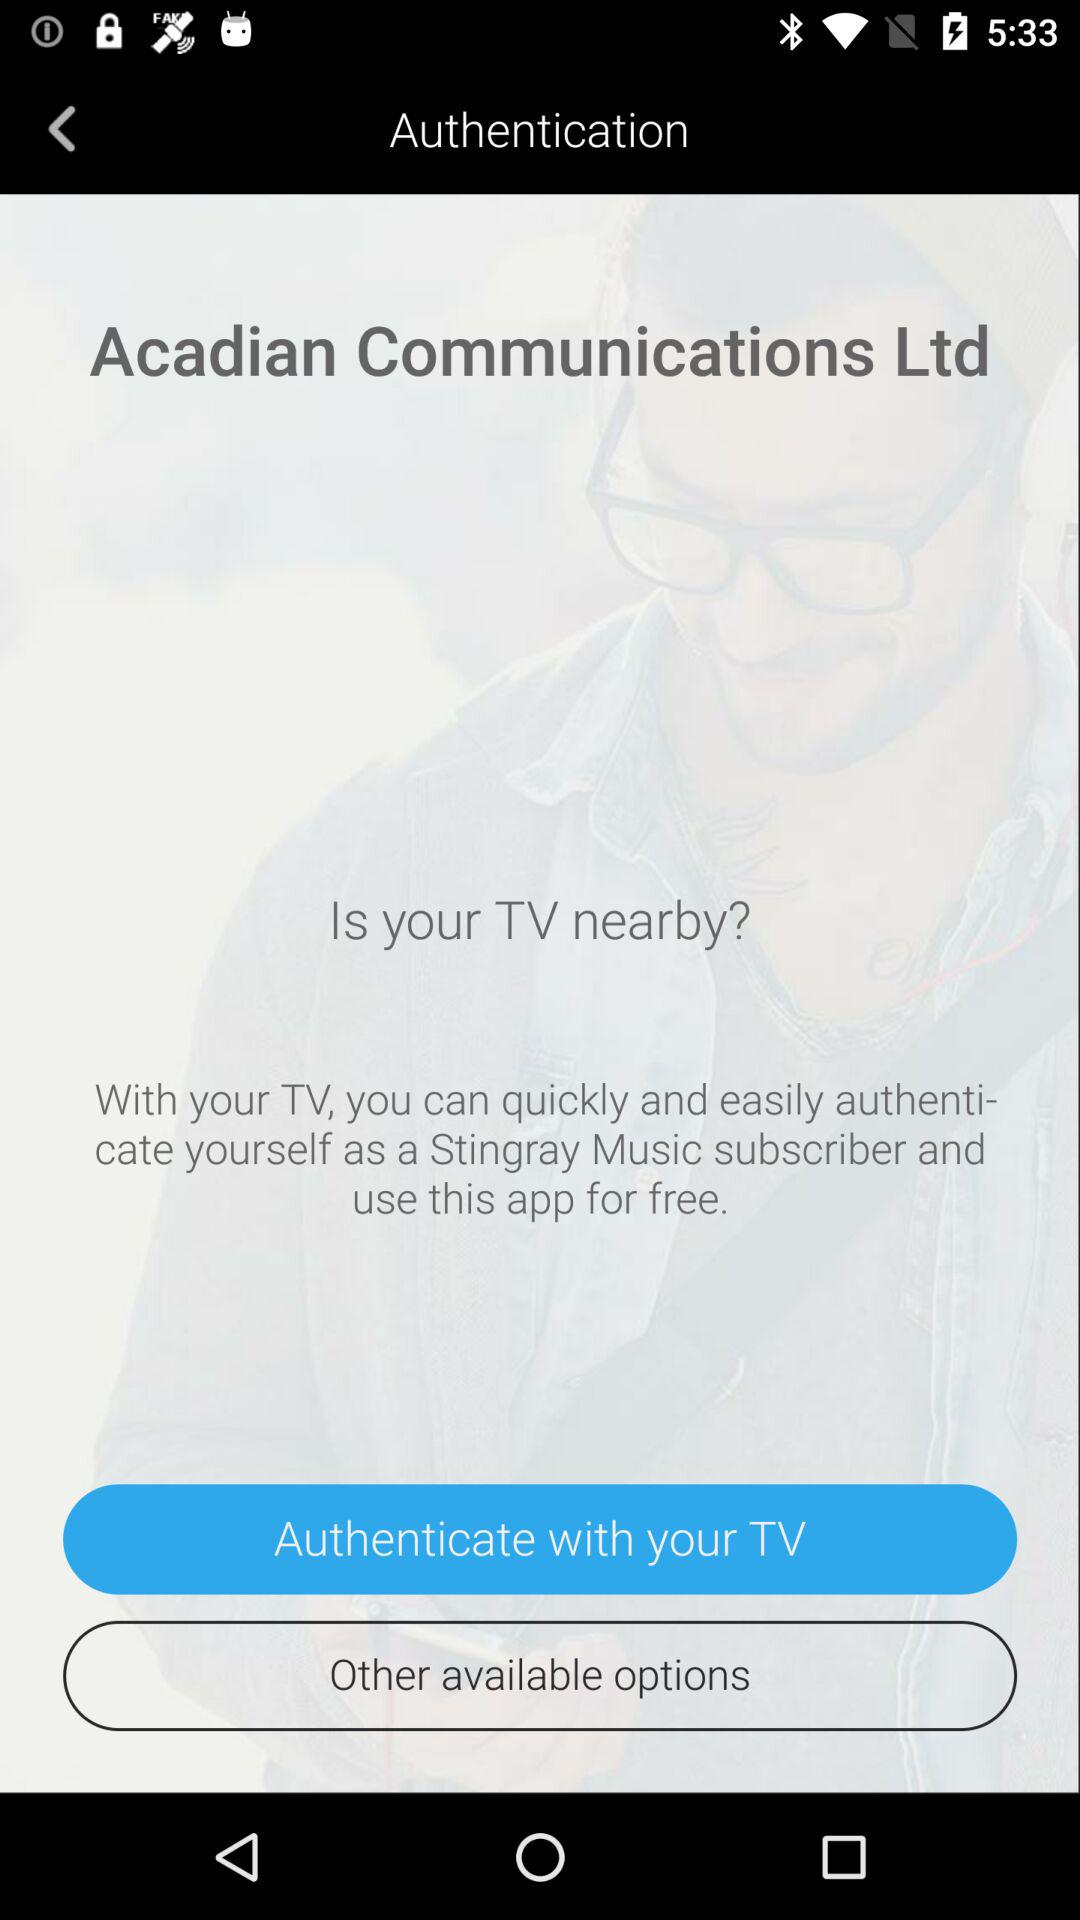What are the other available options?
When the provided information is insufficient, respond with <no answer>. <no answer> 